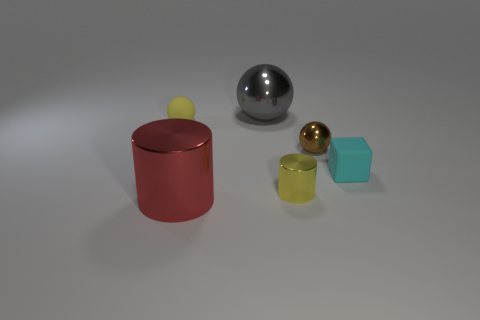There is a brown thing that is the same size as the yellow matte object; what is its shape?
Your response must be concise. Sphere. Do the matte object that is to the right of the small yellow metallic cylinder and the yellow object that is in front of the small yellow matte ball have the same size?
Ensure brevity in your answer.  Yes. What color is the big ball that is the same material as the tiny cylinder?
Your response must be concise. Gray. Are the tiny yellow object behind the brown shiny ball and the small yellow thing in front of the small shiny sphere made of the same material?
Offer a terse response. No. Are there any brown things that have the same size as the brown metal ball?
Provide a succinct answer. No. What size is the rubber object on the right side of the rubber object behind the cyan thing?
Your answer should be very brief. Small. How many small metal cylinders have the same color as the small rubber sphere?
Your answer should be compact. 1. The matte object on the right side of the cylinder that is to the left of the big metal sphere is what shape?
Offer a terse response. Cube. What number of gray spheres have the same material as the brown sphere?
Your answer should be very brief. 1. What material is the tiny yellow thing that is in front of the brown metal ball?
Provide a succinct answer. Metal. 